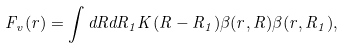<formula> <loc_0><loc_0><loc_500><loc_500>F _ { v } ( r ) = \int d { R } d { R } _ { 1 } K ( { R } - { R } _ { 1 } ) \beta ( { r } , { R } ) \beta ( { r } , { R } _ { 1 } ) ,</formula> 